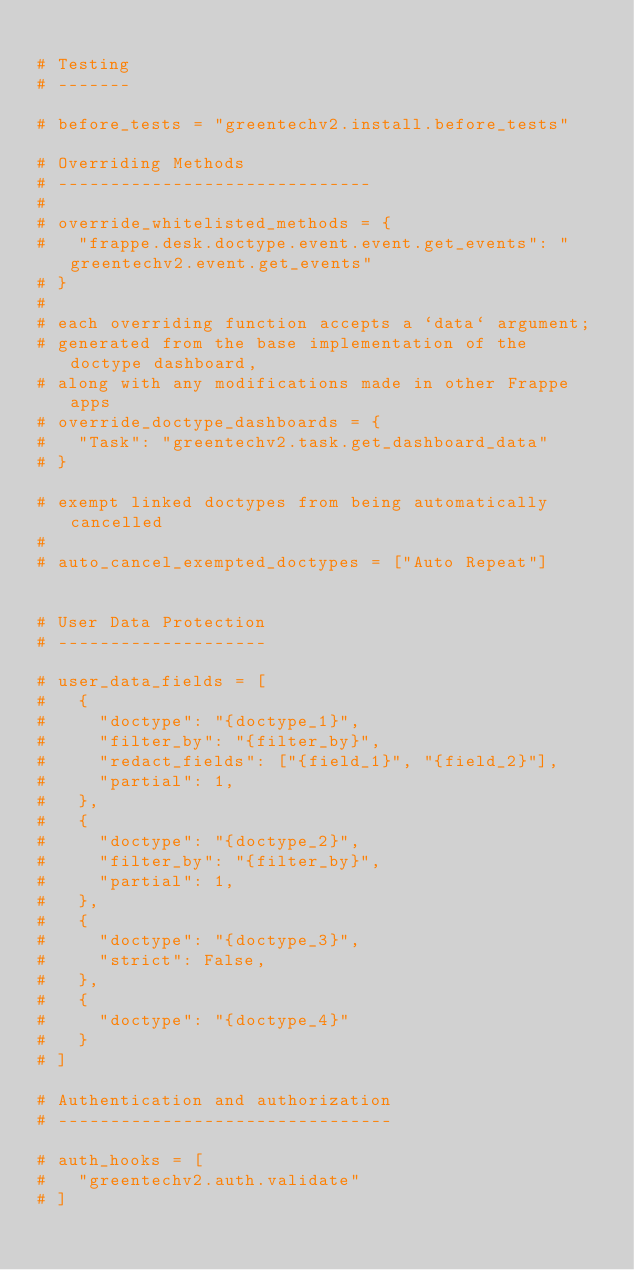Convert code to text. <code><loc_0><loc_0><loc_500><loc_500><_Python_>
# Testing
# -------

# before_tests = "greentechv2.install.before_tests"

# Overriding Methods
# ------------------------------
#
# override_whitelisted_methods = {
# 	"frappe.desk.doctype.event.event.get_events": "greentechv2.event.get_events"
# }
#
# each overriding function accepts a `data` argument;
# generated from the base implementation of the doctype dashboard,
# along with any modifications made in other Frappe apps
# override_doctype_dashboards = {
# 	"Task": "greentechv2.task.get_dashboard_data"
# }

# exempt linked doctypes from being automatically cancelled
#
# auto_cancel_exempted_doctypes = ["Auto Repeat"]


# User Data Protection
# --------------------

# user_data_fields = [
# 	{
# 		"doctype": "{doctype_1}",
# 		"filter_by": "{filter_by}",
# 		"redact_fields": ["{field_1}", "{field_2}"],
# 		"partial": 1,
# 	},
# 	{
# 		"doctype": "{doctype_2}",
# 		"filter_by": "{filter_by}",
# 		"partial": 1,
# 	},
# 	{
# 		"doctype": "{doctype_3}",
# 		"strict": False,
# 	},
# 	{
# 		"doctype": "{doctype_4}"
# 	}
# ]

# Authentication and authorization
# --------------------------------

# auth_hooks = [
# 	"greentechv2.auth.validate"
# ]

</code> 